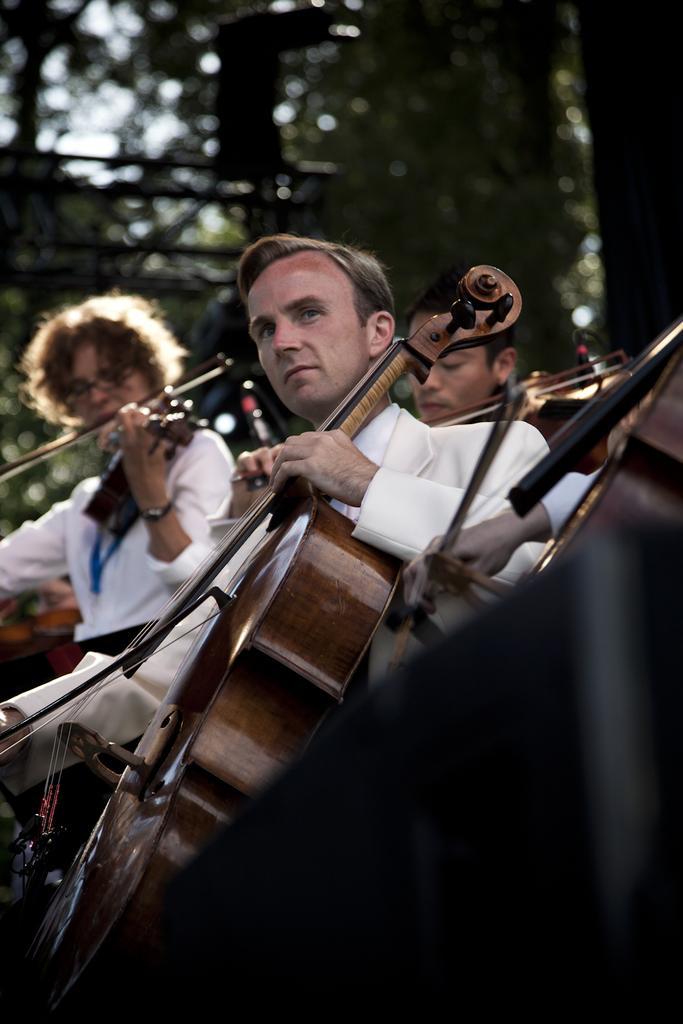In one or two sentences, can you explain what this image depicts? There are four people. They are playing a musical instruments. We can see in background trees. 